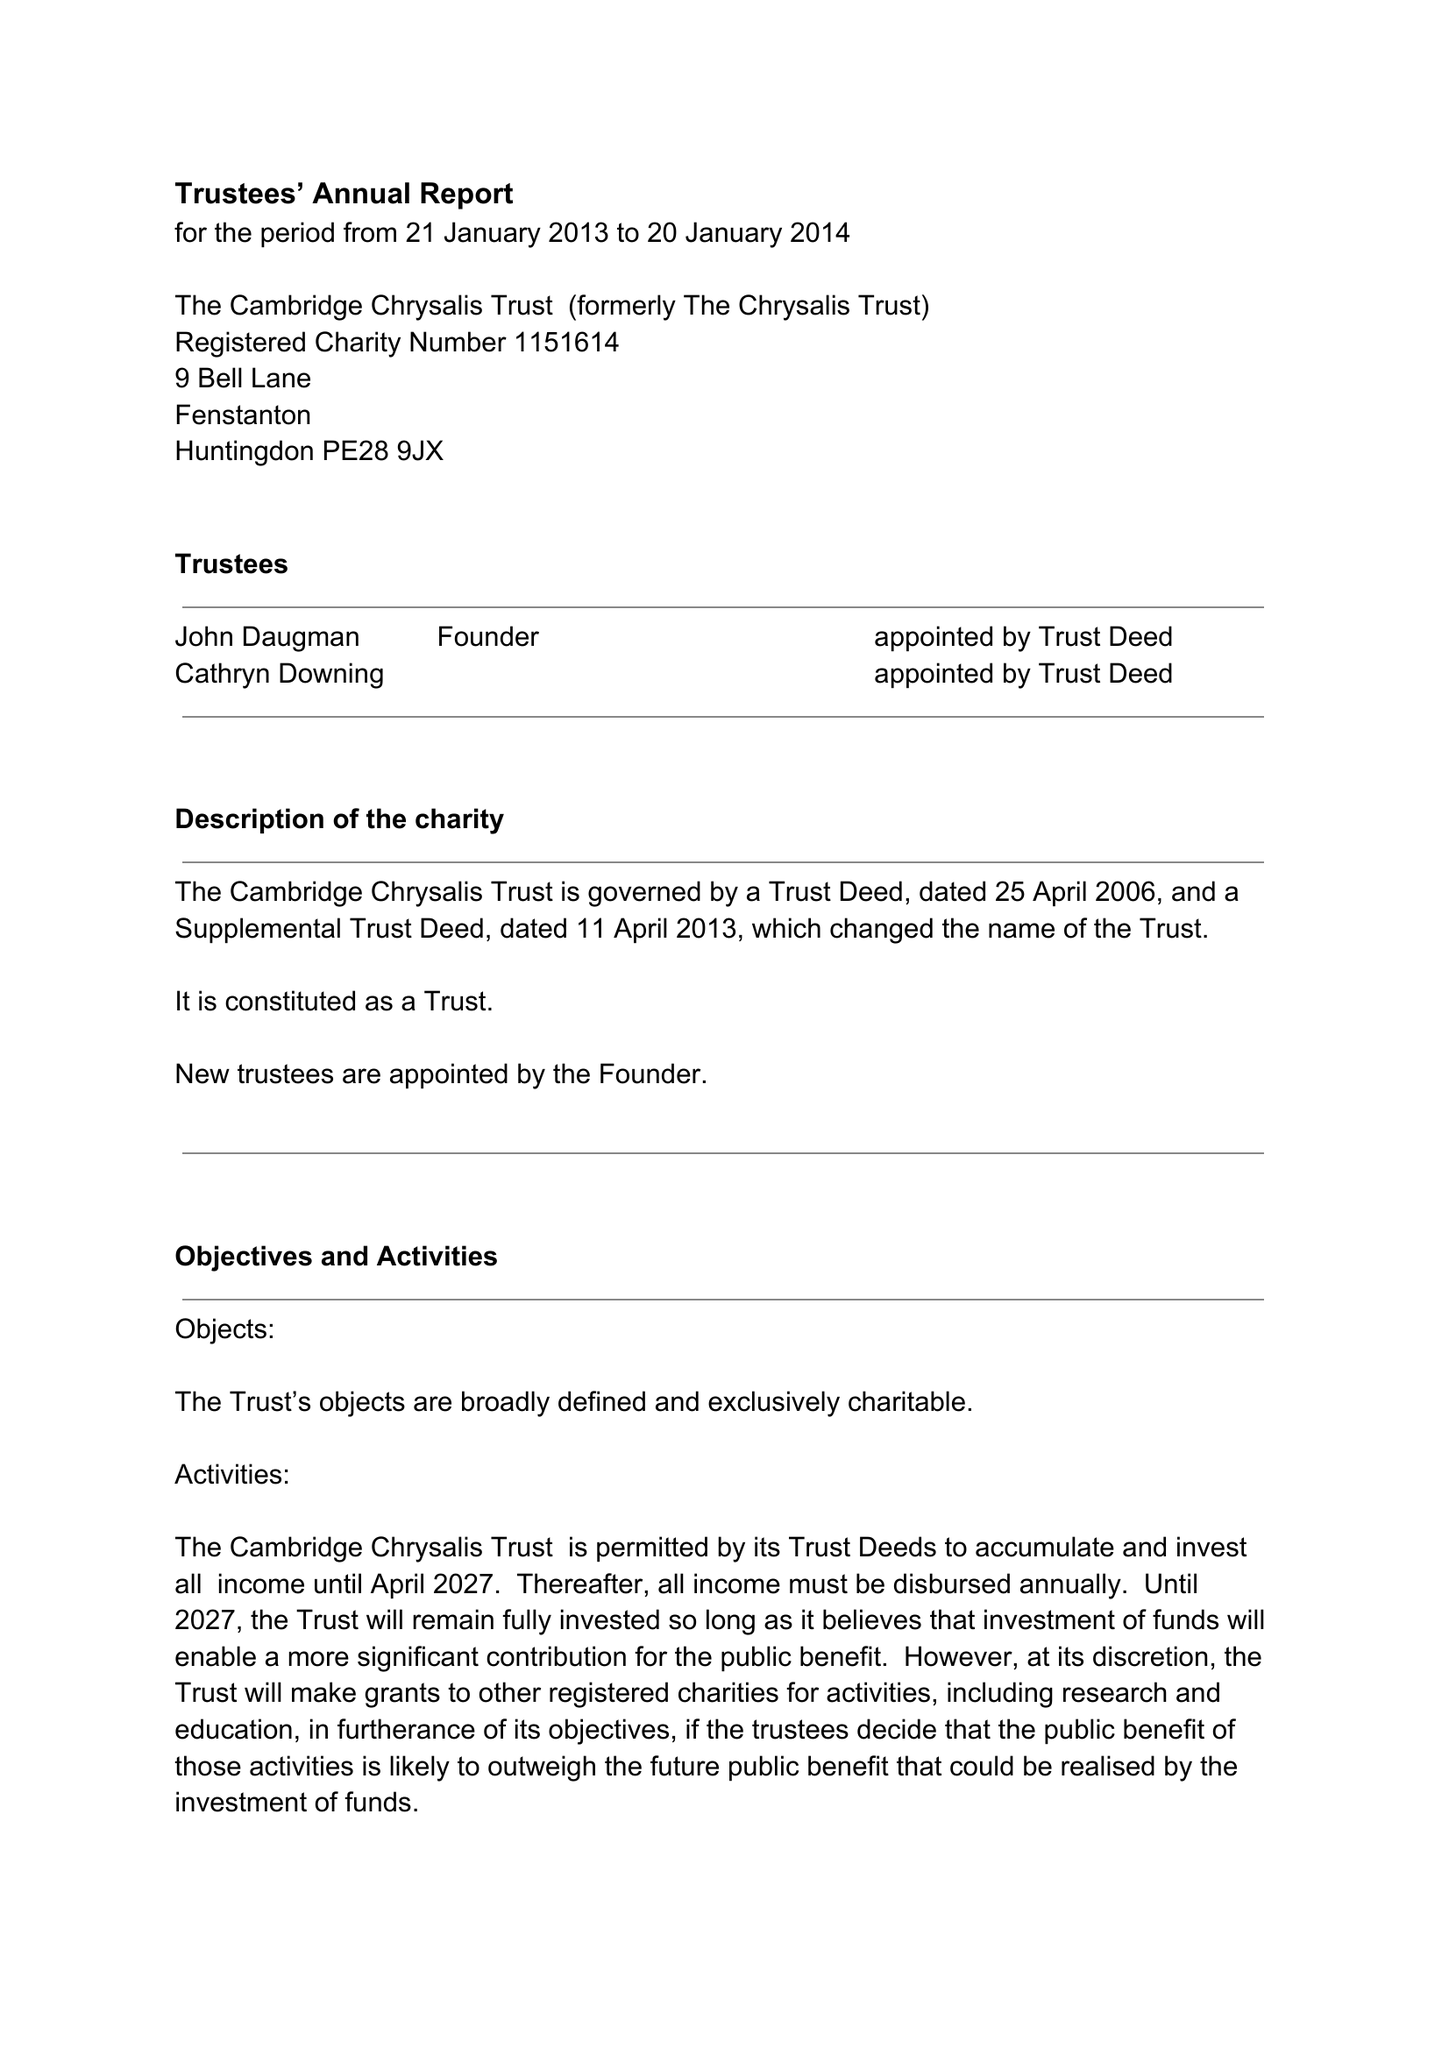What is the value for the charity_name?
Answer the question using a single word or phrase. The Cambridge Chrysalis Trust 